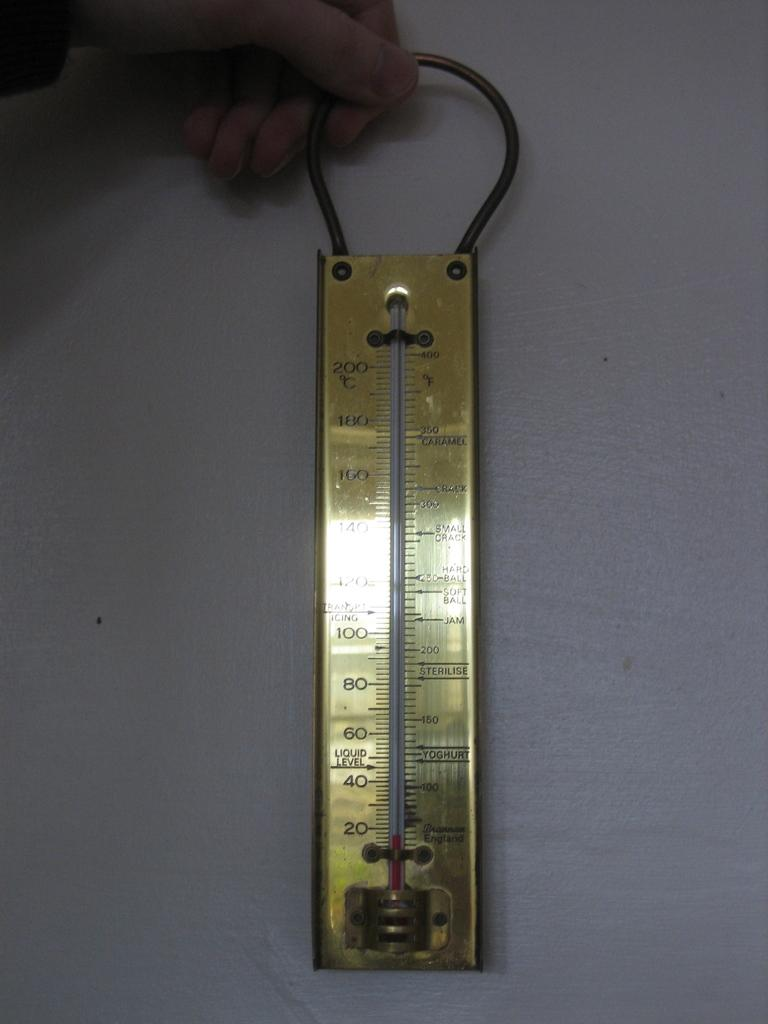<image>
Share a concise interpretation of the image provided. a hand holding a golden thermostat with the numbers 20 and 200 on it. 